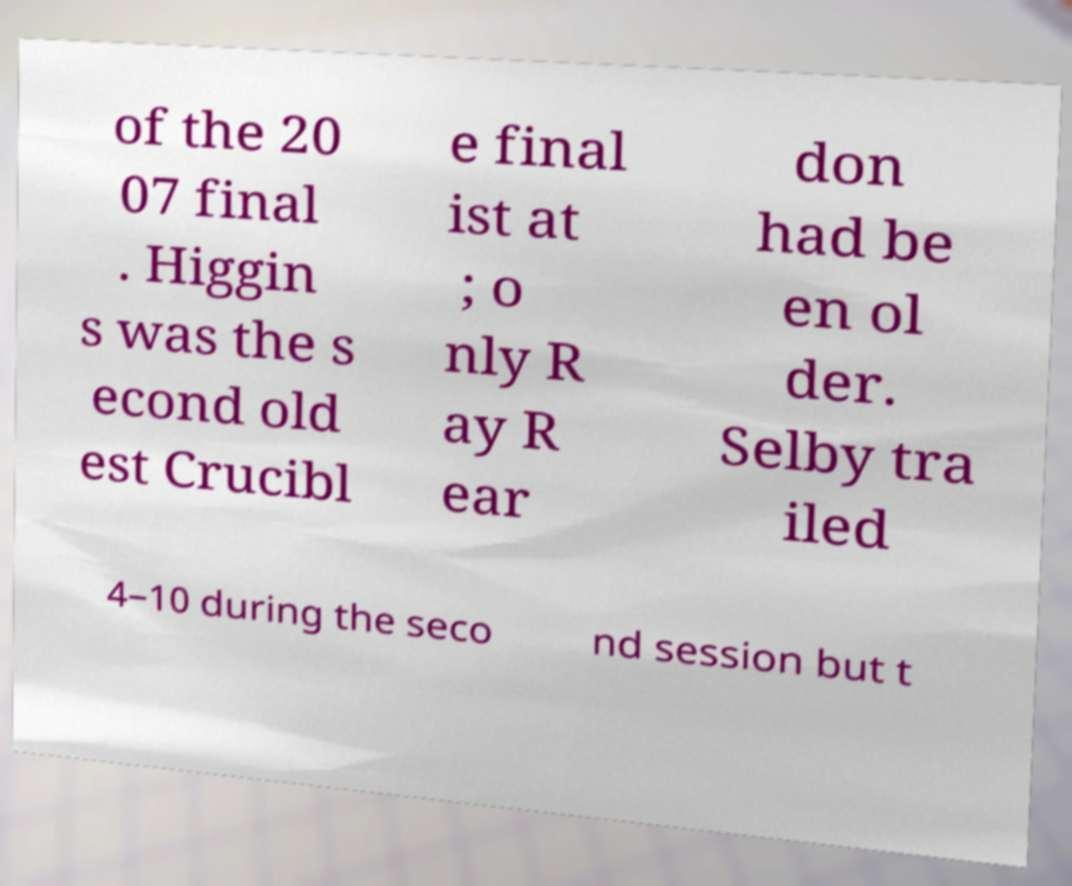Can you accurately transcribe the text from the provided image for me? of the 20 07 final . Higgin s was the s econd old est Crucibl e final ist at ; o nly R ay R ear don had be en ol der. Selby tra iled 4–10 during the seco nd session but t 